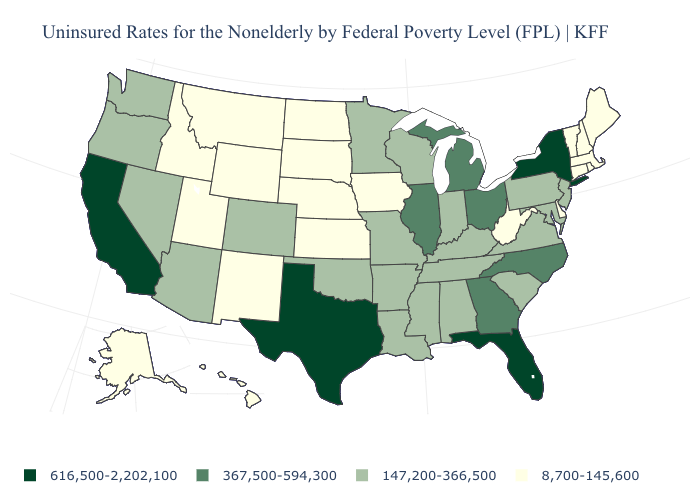What is the value of West Virginia?
Quick response, please. 8,700-145,600. What is the value of Washington?
Quick response, please. 147,200-366,500. Does Hawaii have the highest value in the USA?
Answer briefly. No. What is the value of Virginia?
Be succinct. 147,200-366,500. What is the lowest value in the USA?
Keep it brief. 8,700-145,600. What is the lowest value in the Northeast?
Quick response, please. 8,700-145,600. How many symbols are there in the legend?
Answer briefly. 4. What is the value of Utah?
Write a very short answer. 8,700-145,600. Does the map have missing data?
Quick response, please. No. Name the states that have a value in the range 616,500-2,202,100?
Give a very brief answer. California, Florida, New York, Texas. Name the states that have a value in the range 616,500-2,202,100?
Answer briefly. California, Florida, New York, Texas. Name the states that have a value in the range 616,500-2,202,100?
Short answer required. California, Florida, New York, Texas. What is the value of Texas?
Quick response, please. 616,500-2,202,100. Which states have the highest value in the USA?
Quick response, please. California, Florida, New York, Texas. What is the highest value in the MidWest ?
Quick response, please. 367,500-594,300. 